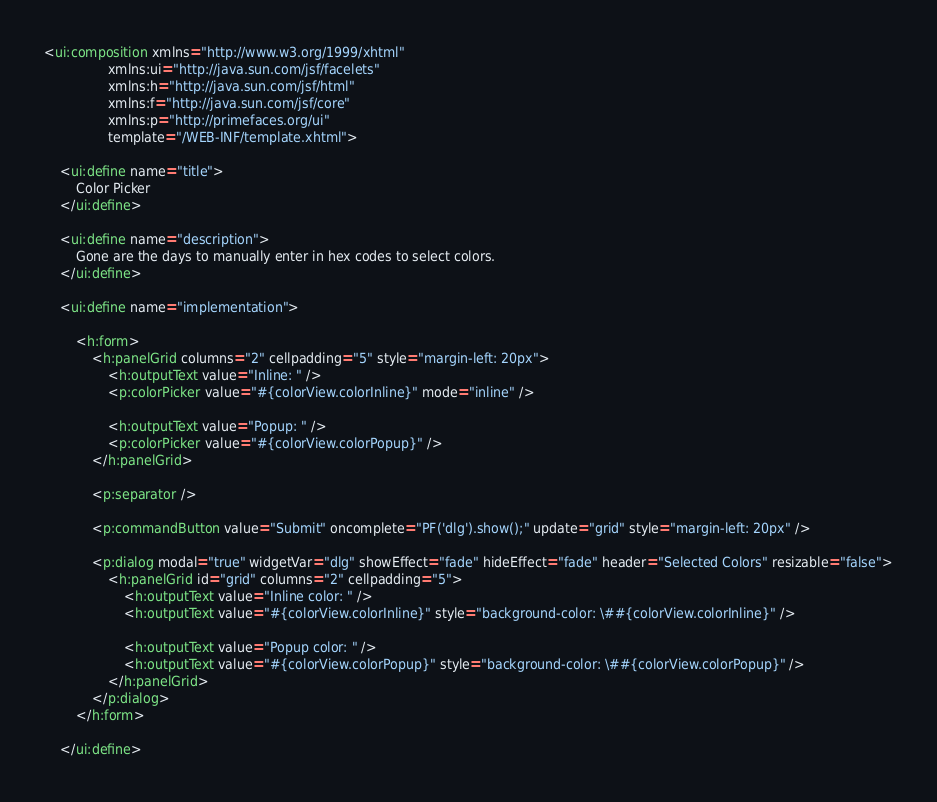<code> <loc_0><loc_0><loc_500><loc_500><_HTML_><ui:composition xmlns="http://www.w3.org/1999/xhtml"
                xmlns:ui="http://java.sun.com/jsf/facelets"
                xmlns:h="http://java.sun.com/jsf/html"
                xmlns:f="http://java.sun.com/jsf/core"
                xmlns:p="http://primefaces.org/ui"
                template="/WEB-INF/template.xhtml">

    <ui:define name="title">
        Color Picker
    </ui:define>

    <ui:define name="description">
        Gone are the days to manually enter in hex codes to select colors.
    </ui:define>

    <ui:define name="implementation">

        <h:form>    
            <h:panelGrid columns="2" cellpadding="5" style="margin-left: 20px">
                <h:outputText value="Inline: " />
                <p:colorPicker value="#{colorView.colorInline}" mode="inline" />

                <h:outputText value="Popup: " />
                <p:colorPicker value="#{colorView.colorPopup}" />                   
            </h:panelGrid>

            <p:separator />

            <p:commandButton value="Submit" oncomplete="PF('dlg').show();" update="grid" style="margin-left: 20px" />
            
            <p:dialog modal="true" widgetVar="dlg" showEffect="fade" hideEffect="fade" header="Selected Colors" resizable="false">
                <h:panelGrid id="grid" columns="2" cellpadding="5">
                    <h:outputText value="Inline color: " />
                    <h:outputText value="#{colorView.colorInline}" style="background-color: \##{colorView.colorInline}" />
                    
                    <h:outputText value="Popup color: " />
                    <h:outputText value="#{colorView.colorPopup}" style="background-color: \##{colorView.colorPopup}" />
                </h:panelGrid>
            </p:dialog>     
        </h:form>
 
    </ui:define>
</code> 